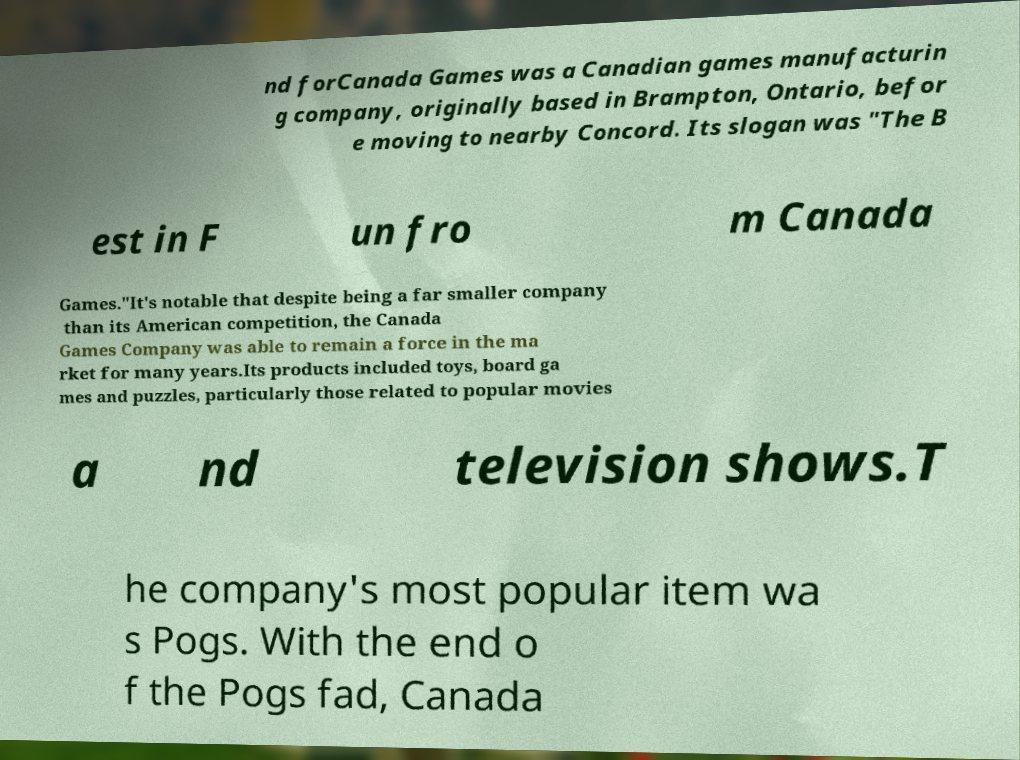For documentation purposes, I need the text within this image transcribed. Could you provide that? nd forCanada Games was a Canadian games manufacturin g company, originally based in Brampton, Ontario, befor e moving to nearby Concord. Its slogan was "The B est in F un fro m Canada Games."It's notable that despite being a far smaller company than its American competition, the Canada Games Company was able to remain a force in the ma rket for many years.Its products included toys, board ga mes and puzzles, particularly those related to popular movies a nd television shows.T he company's most popular item wa s Pogs. With the end o f the Pogs fad, Canada 